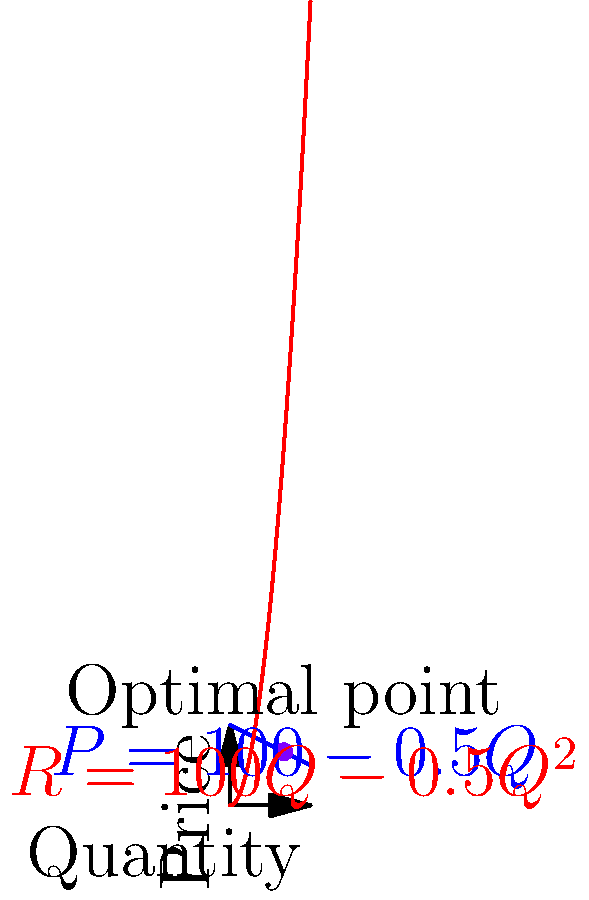As the CEO, you're analyzing a demand curve for a new product line. The demand function is given by $P = 100 - 0.5Q$, where $P$ is the price and $Q$ is the quantity demanded. The total revenue function is $R = PQ$. Using calculus, determine the optimal price point that maximizes revenue. How does this information impact your pricing strategy? To find the optimal price point that maximizes revenue, we'll follow these steps:

1) First, express the revenue function in terms of Q:
   $R = PQ = (100 - 0.5Q)Q = 100Q - 0.5Q^2$

2) To find the maximum revenue, we need to find where the derivative of R with respect to Q equals zero:
   $\frac{dR}{dQ} = 100 - Q = 0$

3) Solve for Q:
   $100 - Q = 0$
   $Q = 100$

4) This gives us the quantity that maximizes revenue. To find the optimal price, substitute this Q back into the demand function:
   $P = 100 - 0.5(100) = 50$

5) Therefore, the optimal point is (Q, P) = (100, 50).

6) To verify this is a maximum, we can check the second derivative:
   $\frac{d^2R}{dQ^2} = -1 < 0$, confirming it's a maximum.

7) The maximum revenue is:
   $R_{max} = 100(100) - 0.5(100)^2 = 5000$

Impact on pricing strategy:
This analysis suggests setting the price at $50 to maximize revenue. However, as CEO, you should consider other factors:
- Costs: Ensure this price point allows for sufficient profit margins.
- Market positioning: This price might affect brand perception.
- Competitive landscape: How does this price compare to competitors?
- Demand elasticity: How sensitive are customers to price changes?
- Long-term strategy: Consider if maximizing short-term revenue aligns with long-term goals.

This data-driven approach provides a starting point for pricing discussions with your VP of Sales, allowing for a more informed decision-making process.
Answer: Set price at $50 for maximum revenue of $5000, but consider other strategic factors before final decision. 